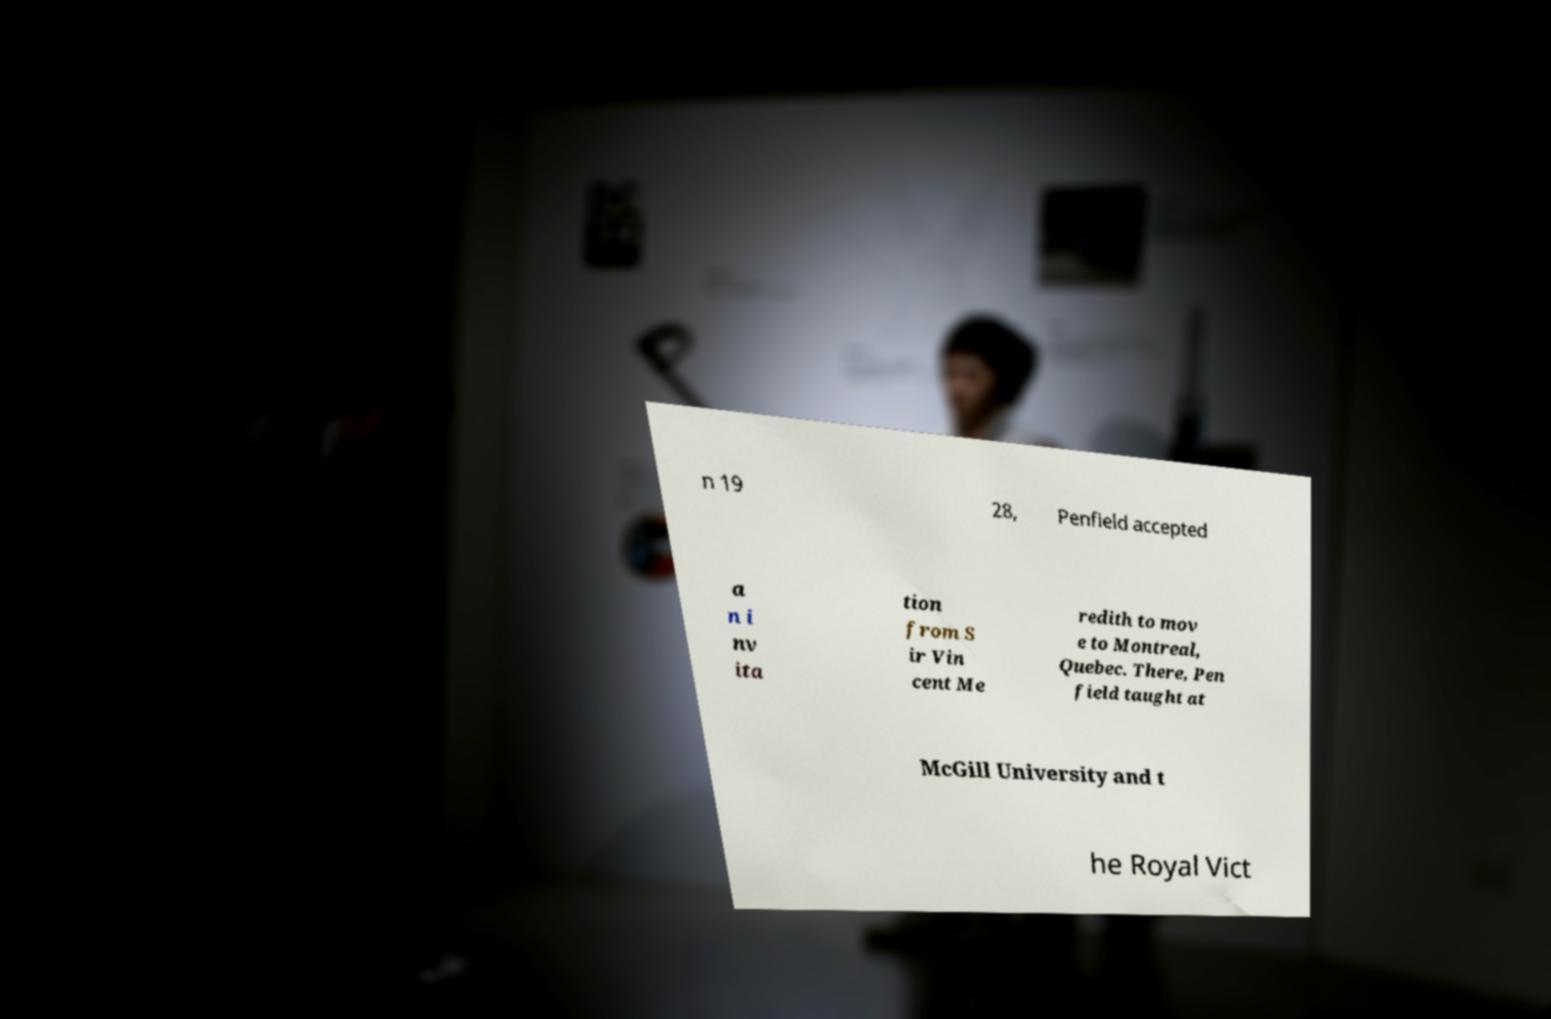Please identify and transcribe the text found in this image. n 19 28, Penfield accepted a n i nv ita tion from S ir Vin cent Me redith to mov e to Montreal, Quebec. There, Pen field taught at McGill University and t he Royal Vict 